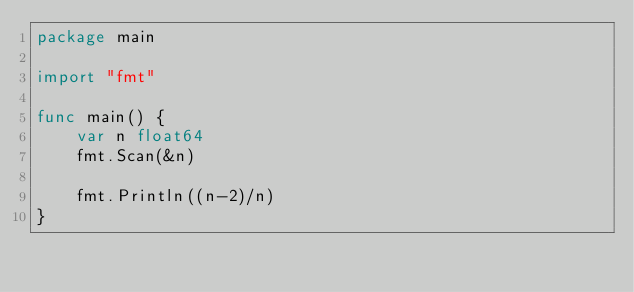Convert code to text. <code><loc_0><loc_0><loc_500><loc_500><_Go_>package main

import "fmt"

func main() {
	var n float64
	fmt.Scan(&n)

	fmt.Println((n-2)/n)
}
</code> 